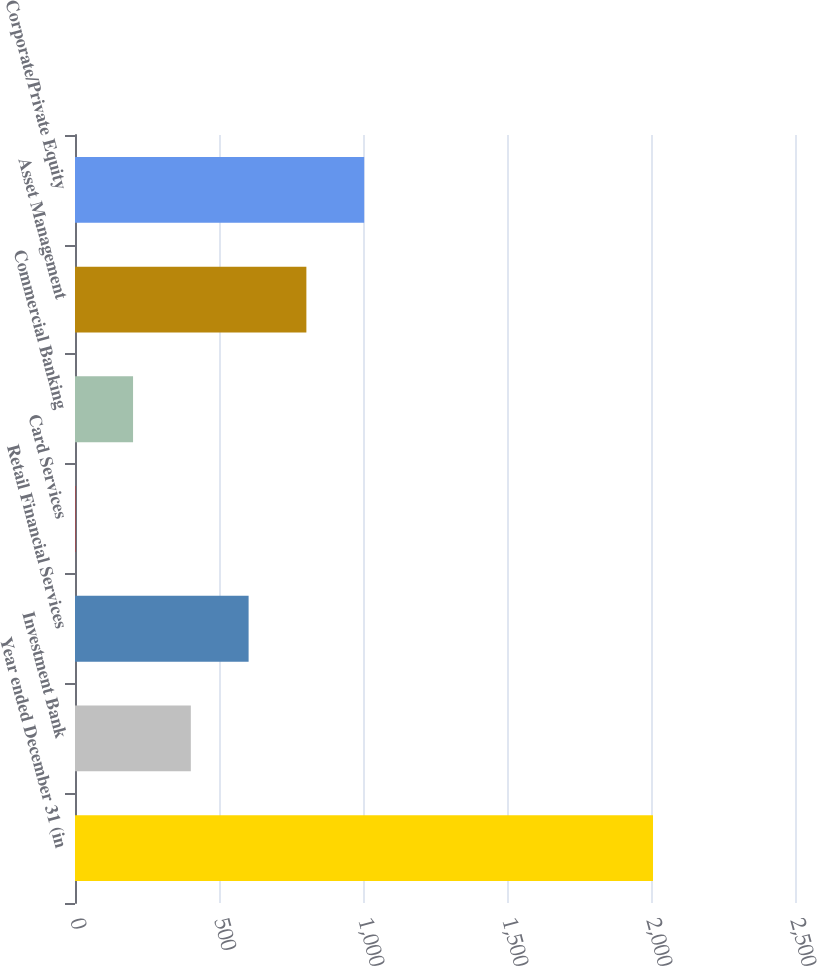Convert chart to OTSL. <chart><loc_0><loc_0><loc_500><loc_500><bar_chart><fcel>Year ended December 31 (in<fcel>Investment Bank<fcel>Retail Financial Services<fcel>Card Services<fcel>Commercial Banking<fcel>Asset Management<fcel>Corporate/Private Equity<nl><fcel>2007<fcel>402.2<fcel>602.8<fcel>1<fcel>201.6<fcel>803.4<fcel>1004<nl></chart> 